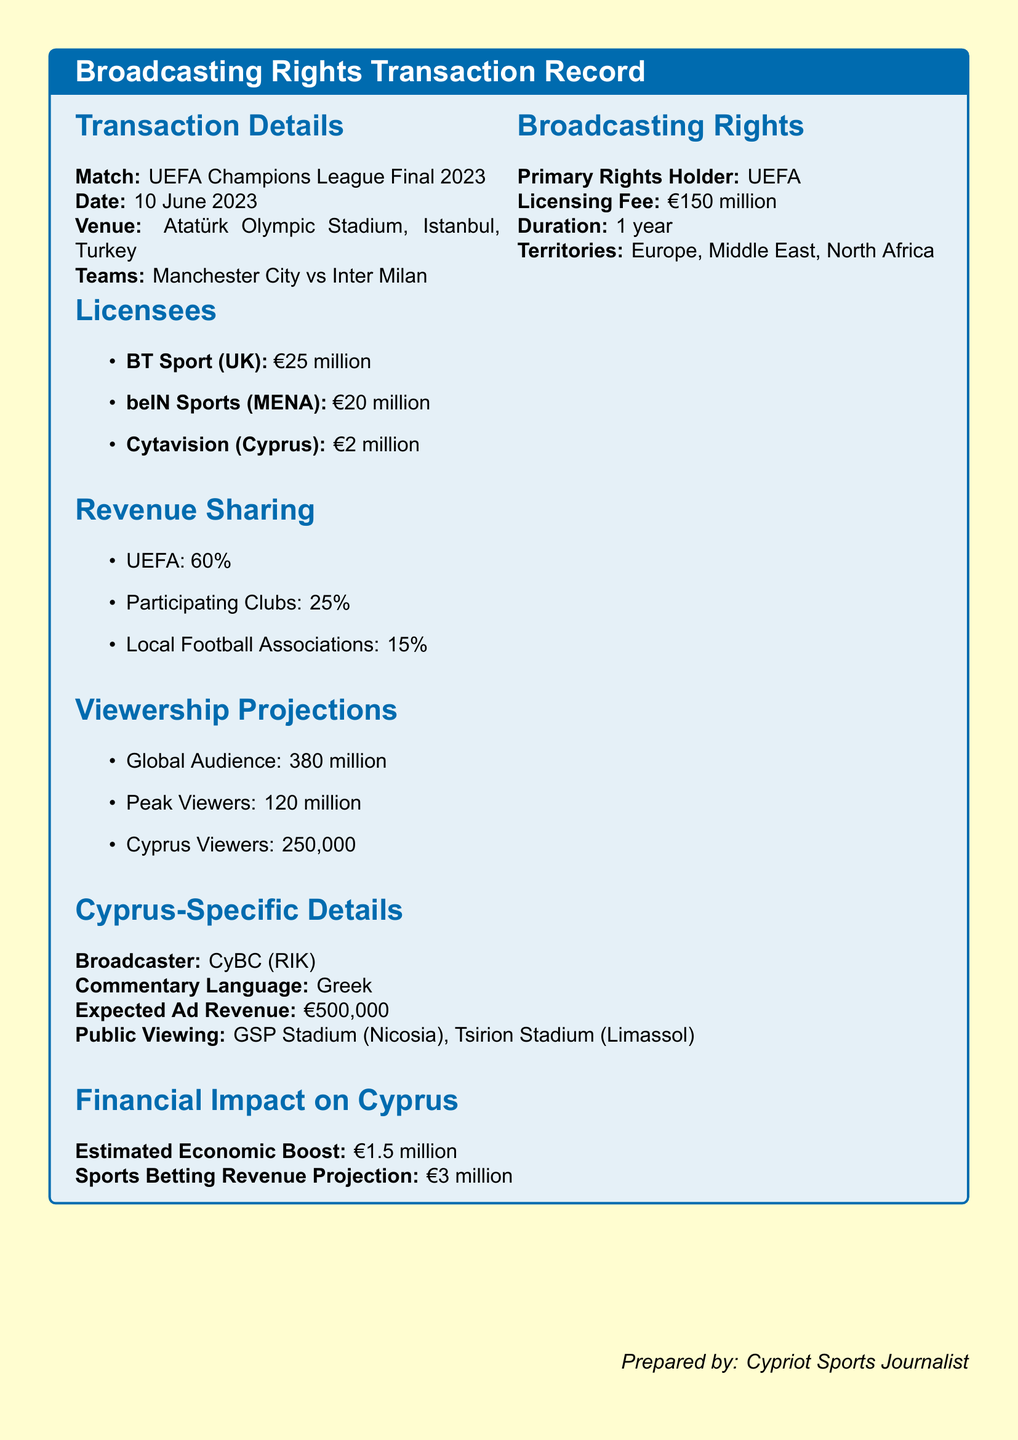What is the licensing fee for the broadcasting rights? The licensing fee is specified at the beginning of the document under broadcasting rights.
Answer: €150 million Who are the teams playing in the UEFA Champions League Final 2023? The names of the teams are listed in the transaction details section of the document.
Answer: Manchester City, Inter Milan What is the expected ad revenue for the broadcaster in Cyprus? The expected ad revenue is mentioned in the Cyprus-specific details section of the document.
Answer: €500,000 How many viewers are projected in Cyprus? The viewership projections section of the document provides specific audience figures for Cyprus.
Answer: 250,000 What percentage of revenue goes to UEFA? The revenue sharing section outlines the distributions, including the percentage for UEFA.
Answer: 60% What is the venue for the match? The venue for the event is clearly stated in the transaction details section of the document.
Answer: Atatürk Olympic Stadium, Istanbul, Turkey Which broadcasting agency is responsible for the commentary in Cyprus? The Cyprus-specific details section indicates which broadcaster is providing the commentary.
Answer: CyBC (RIK) What is the duration of the licensing rights? The duration for which the licensing fee applies is mentioned in the broadcasting rights section.
Answer: 1 year How many total licensees are listed in the document? The licensees are enumerated in a list format within the corresponding section of the document.
Answer: 3 